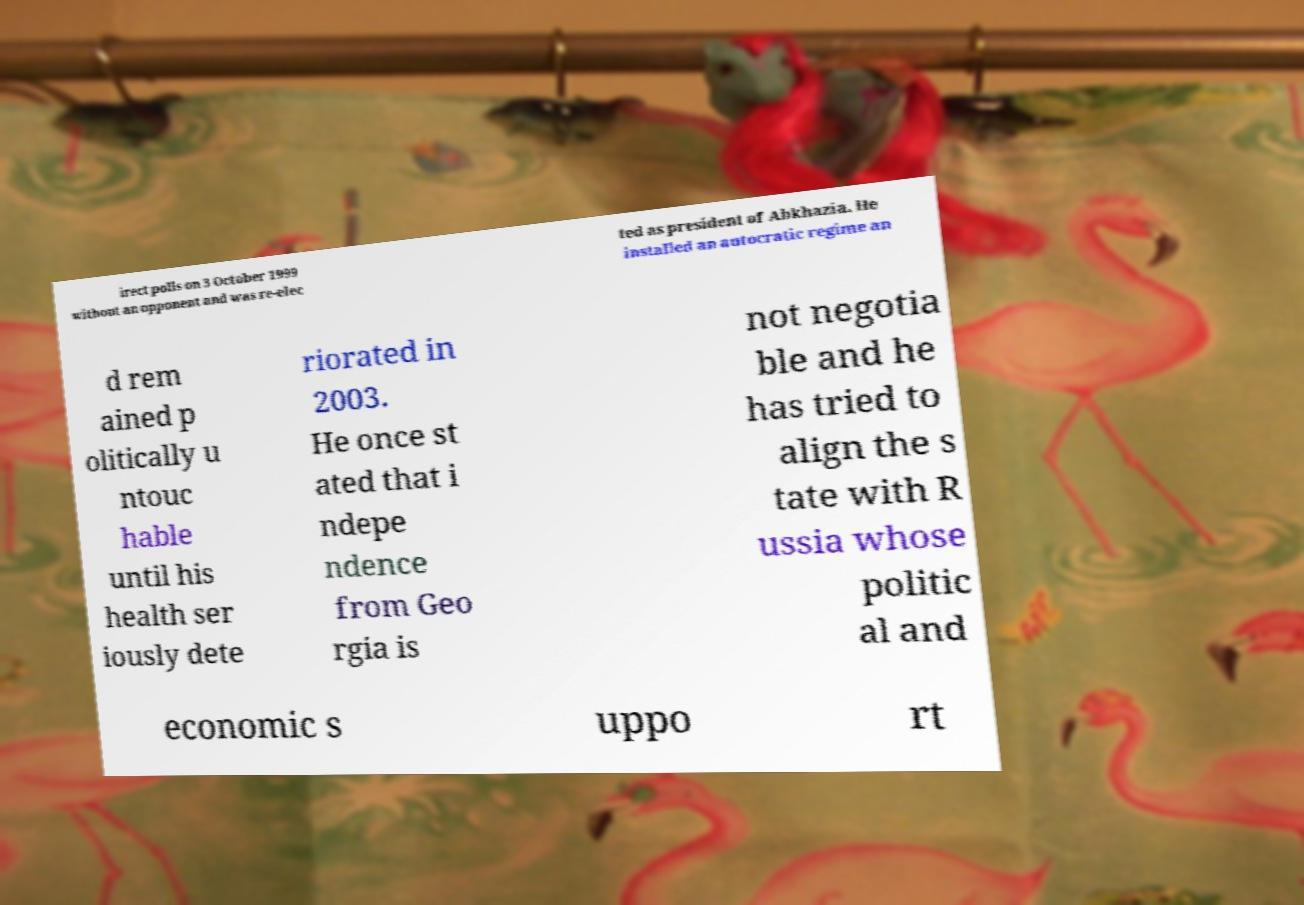What messages or text are displayed in this image? I need them in a readable, typed format. irect polls on 3 October 1999 without an opponent and was re-elec ted as president of Abkhazia. He installed an autocratic regime an d rem ained p olitically u ntouc hable until his health ser iously dete riorated in 2003. He once st ated that i ndepe ndence from Geo rgia is not negotia ble and he has tried to align the s tate with R ussia whose politic al and economic s uppo rt 